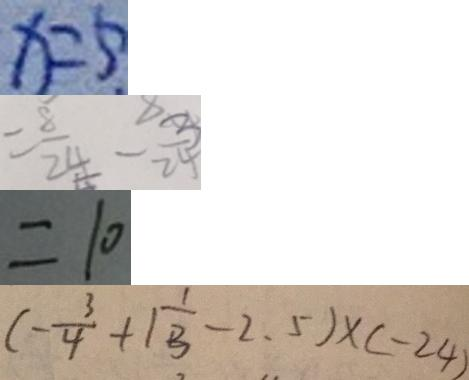<formula> <loc_0><loc_0><loc_500><loc_500>x = 5 
 = \frac { 8 } { 2 4 } - \frac { 3 } { 2 4 } 
 = 1 0 
 ( - \frac { 3 } { 4 } + 1 \frac { 1 } { 3 } - 2 . 5 ) \times ( - 2 4 )</formula> 